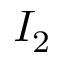<formula> <loc_0><loc_0><loc_500><loc_500>I _ { 2 }</formula> 